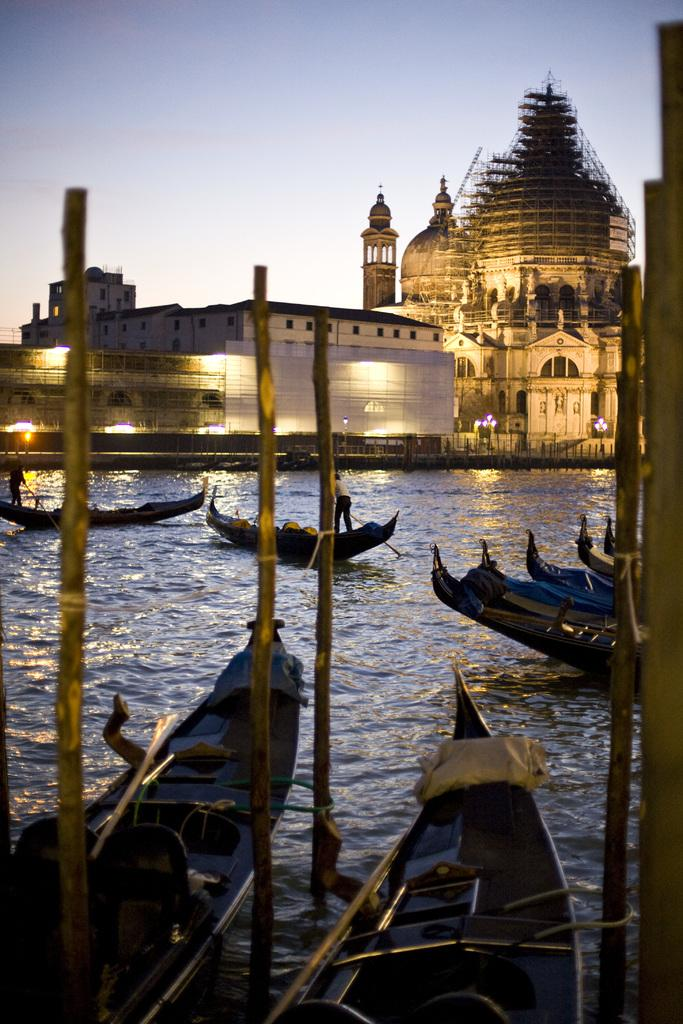What can be seen in the foreground of the image? There are two boats in the foreground of the image, tied to poles. What is visible in the background of the image? In the background, there are boats on the water, lights, buildings, and the sky. How are the boats in the foreground positioned? The boats in the foreground are tied to poles. What type of structures can be seen in the background? There are buildings in the background. How many years of experience does the beginner boat driver have in the image? There is no information about a boat driver or their experience level in the image. 